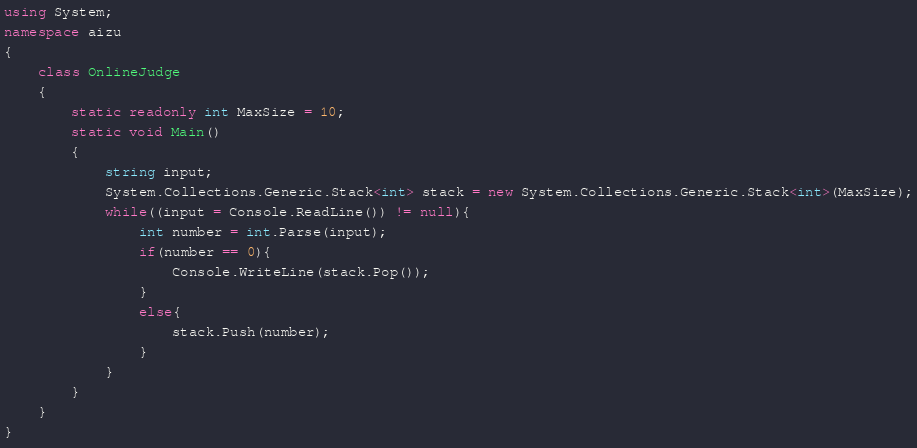Convert code to text. <code><loc_0><loc_0><loc_500><loc_500><_C#_>using System;
namespace aizu
{
    class OnlineJudge
    {
        static readonly int MaxSize = 10;
        static void Main()
        {
            string input;
            System.Collections.Generic.Stack<int> stack = new System.Collections.Generic.Stack<int>(MaxSize);
            while((input = Console.ReadLine()) != null){
                int number = int.Parse(input);
                if(number == 0){
                    Console.WriteLine(stack.Pop());
                }
                else{
                    stack.Push(number);
                }
            }
        }
    }
}</code> 